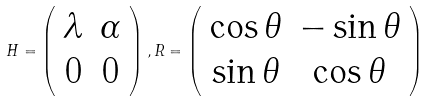Convert formula to latex. <formula><loc_0><loc_0><loc_500><loc_500>H = \left ( \begin{array} { c c } \lambda & \alpha \\ 0 & 0 \end{array} \right ) , R = \left ( \begin{array} { c c } \cos \theta & - \sin \theta \\ \sin \theta & \cos \theta \end{array} \right )</formula> 